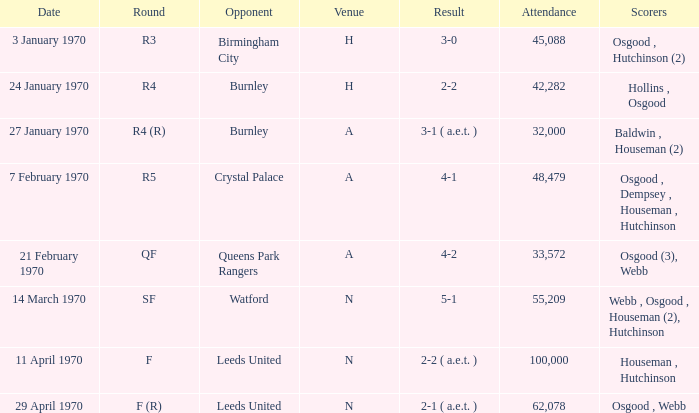During which round was the game with a 5-1 score at n place? SF. 